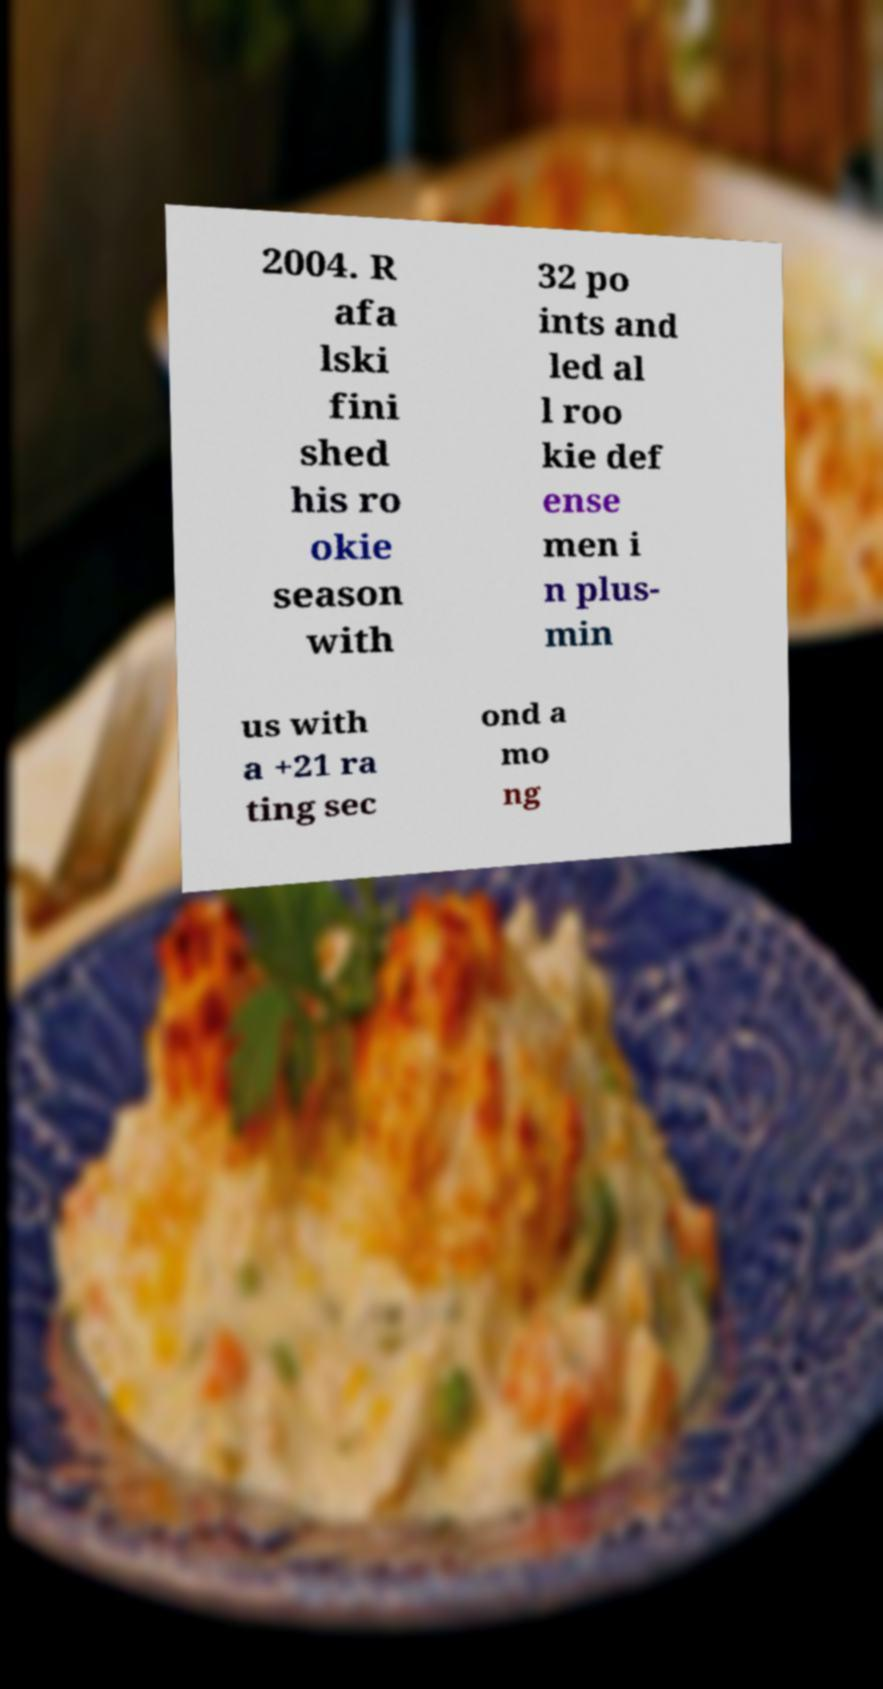Please read and relay the text visible in this image. What does it say? 2004. R afa lski fini shed his ro okie season with 32 po ints and led al l roo kie def ense men i n plus- min us with a +21 ra ting sec ond a mo ng 